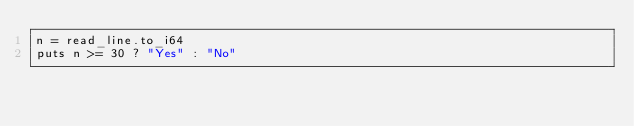Convert code to text. <code><loc_0><loc_0><loc_500><loc_500><_Crystal_>n = read_line.to_i64
puts n >= 30 ? "Yes" : "No"</code> 